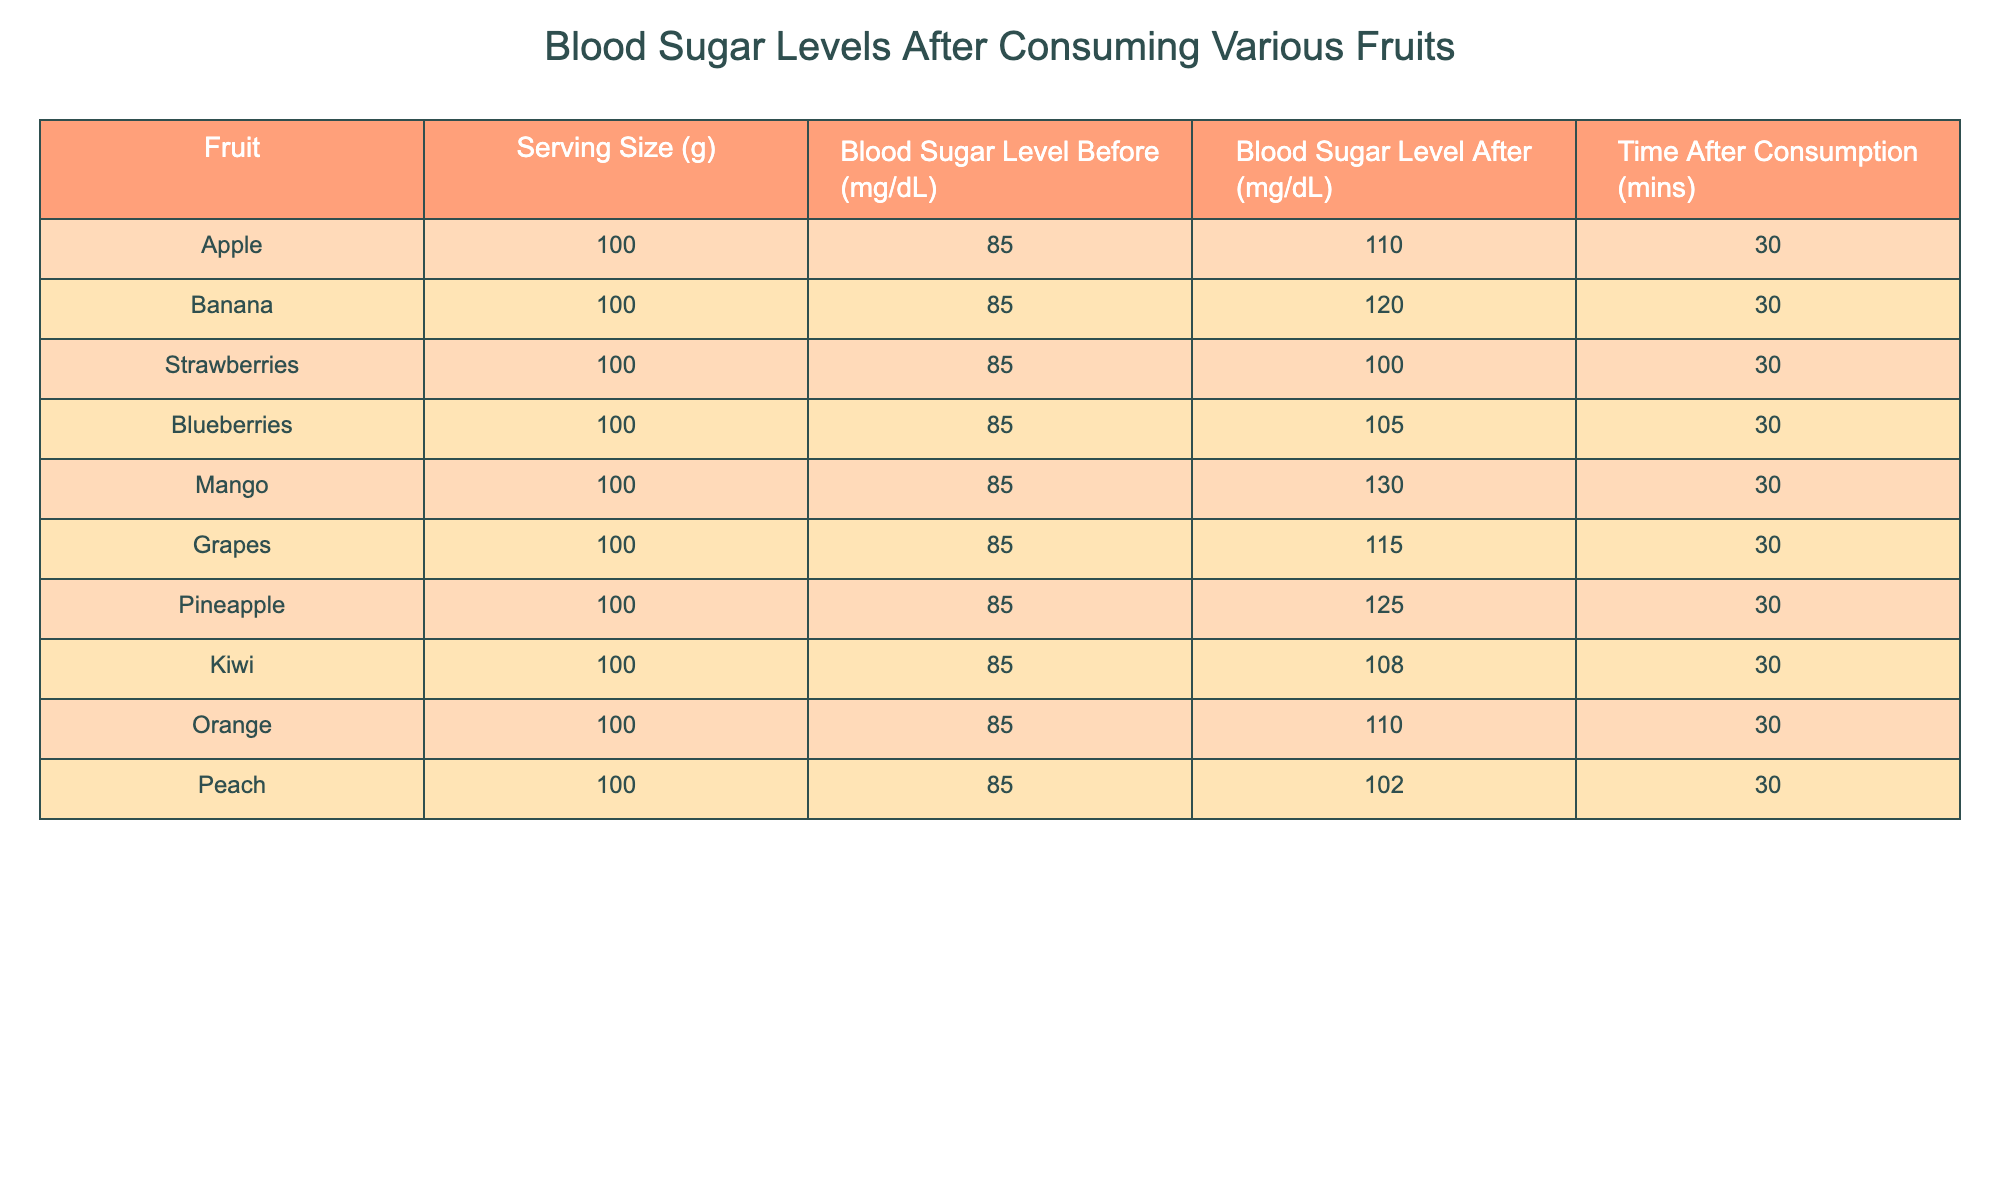What is the blood sugar level for mango after consumption? The table lists the blood sugar level after consuming mango as 130 mg/dL.
Answer: 130 mg/dL Which fruit showed the highest increase in blood sugar level? By comparing the blood sugar levels after consumption for each fruit, mango had the highest blood sugar level after consumption at 130 mg/dL, which is an increase of 45 mg/dL from the initial level of 85 mg/dL.
Answer: Mango What is the blood sugar level for strawberries before consumption? The blood sugar level for strawberries before consumption is listed as 85 mg/dL in the table.
Answer: 85 mg/dL Did consuming grapes result in a blood sugar level over 110 mg/dL? The table shows that the blood sugar level after consuming grapes is 115 mg/dL, which is indeed over 110 mg/dL. Therefore, the answer is yes.
Answer: Yes What is the average blood sugar level after consuming the fruits listed? To calculate the average, we take the sum of all the blood sugar levels after consumption: 110 + 120 + 100 + 105 + 130 + 115 + 125 + 108 + 110 + 102 = 1,135 mg/dL. There are 10 fruits, so the average is 1,135 mg/dL divided by 10, which equals 113.5 mg/dL.
Answer: 113.5 mg/dL What is the difference in blood sugar level after consuming bananas compared to peaches? The blood sugar level after consuming bananas is 120 mg/dL and for peaches, it is 102 mg/dL. The difference is calculated as 120 - 102 = 18 mg/dL.
Answer: 18 mg/dL Is the blood sugar level after consuming oranges the same as after consuming apples? The table shows that the blood sugar level after consuming oranges is 110 mg/dL, while for apples it is also 110 mg/dL, indicating they are the same. Therefore, the answer is yes.
Answer: Yes What fruit resulted in a lower blood sugar level after consumption, kiwi or blueberries? The blood sugar level after consuming kiwi is 108 mg/dL, and for blueberries, it is 105 mg/dL. Kiwi has a higher level, so blueberries resulted in a lower level after consumption.
Answer: Blueberries What percentage increase in blood sugar level does consuming mango represent compared to its initial level? The initial level for mango is 85 mg/dL. The increase after consumption is 130 - 85 = 45 mg/dL. The percentage increase is (45/85) * 100 = 52.94%, which can be rounded to 52.9% when expressed as a whole number.
Answer: 52.9% 